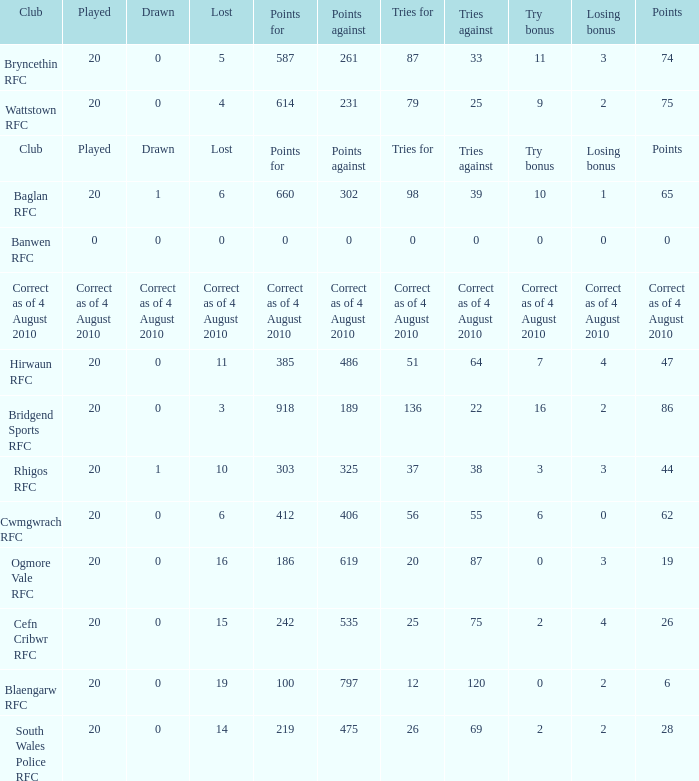What is the points when the club blaengarw rfc? 6.0. 